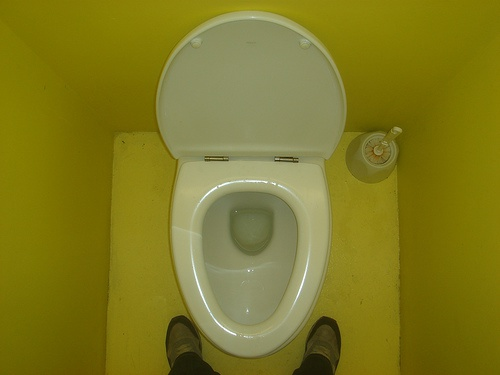Describe the objects in this image and their specific colors. I can see toilet in olive and tan tones and people in olive, black, and darkgreen tones in this image. 